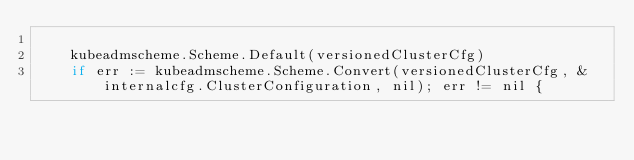Convert code to text. <code><loc_0><loc_0><loc_500><loc_500><_Go_>
	kubeadmscheme.Scheme.Default(versionedClusterCfg)
	if err := kubeadmscheme.Scheme.Convert(versionedClusterCfg, &internalcfg.ClusterConfiguration, nil); err != nil {</code> 